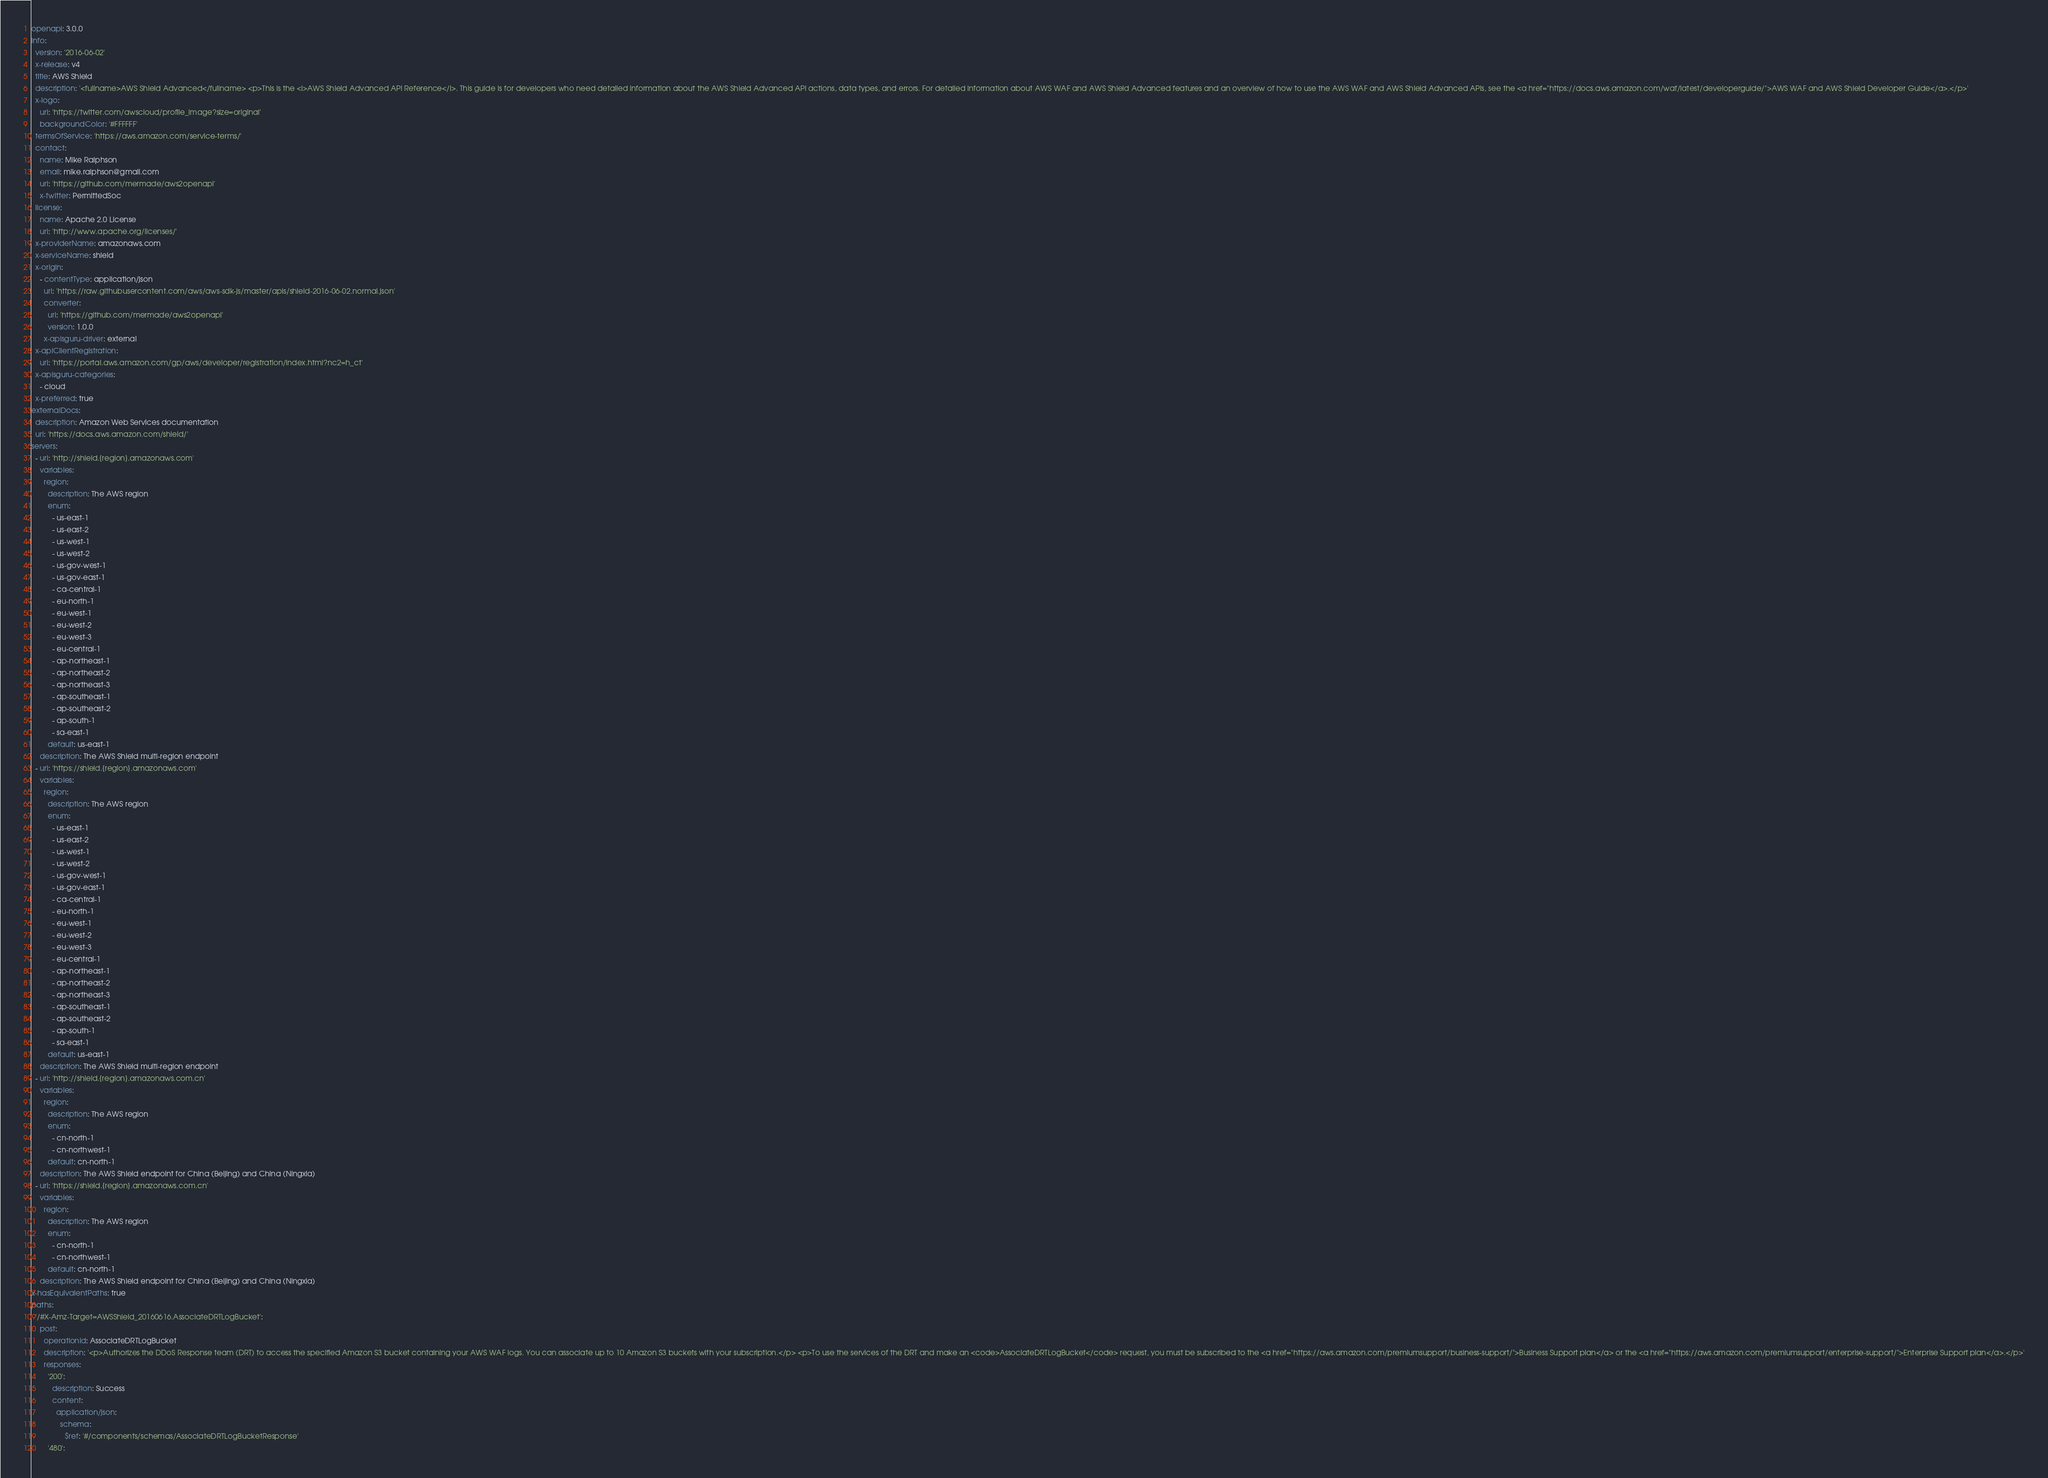Convert code to text. <code><loc_0><loc_0><loc_500><loc_500><_YAML_>openapi: 3.0.0
info:
  version: '2016-06-02'
  x-release: v4
  title: AWS Shield
  description: '<fullname>AWS Shield Advanced</fullname> <p>This is the <i>AWS Shield Advanced API Reference</i>. This guide is for developers who need detailed information about the AWS Shield Advanced API actions, data types, and errors. For detailed information about AWS WAF and AWS Shield Advanced features and an overview of how to use the AWS WAF and AWS Shield Advanced APIs, see the <a href="https://docs.aws.amazon.com/waf/latest/developerguide/">AWS WAF and AWS Shield Developer Guide</a>.</p>'
  x-logo:
    url: 'https://twitter.com/awscloud/profile_image?size=original'
    backgroundColor: '#FFFFFF'
  termsOfService: 'https://aws.amazon.com/service-terms/'
  contact:
    name: Mike Ralphson
    email: mike.ralphson@gmail.com
    url: 'https://github.com/mermade/aws2openapi'
    x-twitter: PermittedSoc
  license:
    name: Apache 2.0 License
    url: 'http://www.apache.org/licenses/'
  x-providerName: amazonaws.com
  x-serviceName: shield
  x-origin:
    - contentType: application/json
      url: 'https://raw.githubusercontent.com/aws/aws-sdk-js/master/apis/shield-2016-06-02.normal.json'
      converter:
        url: 'https://github.com/mermade/aws2openapi'
        version: 1.0.0
      x-apisguru-driver: external
  x-apiClientRegistration:
    url: 'https://portal.aws.amazon.com/gp/aws/developer/registration/index.html?nc2=h_ct'
  x-apisguru-categories:
    - cloud
  x-preferred: true
externalDocs:
  description: Amazon Web Services documentation
  url: 'https://docs.aws.amazon.com/shield/'
servers:
  - url: 'http://shield.{region}.amazonaws.com'
    variables:
      region:
        description: The AWS region
        enum:
          - us-east-1
          - us-east-2
          - us-west-1
          - us-west-2
          - us-gov-west-1
          - us-gov-east-1
          - ca-central-1
          - eu-north-1
          - eu-west-1
          - eu-west-2
          - eu-west-3
          - eu-central-1
          - ap-northeast-1
          - ap-northeast-2
          - ap-northeast-3
          - ap-southeast-1
          - ap-southeast-2
          - ap-south-1
          - sa-east-1
        default: us-east-1
    description: The AWS Shield multi-region endpoint
  - url: 'https://shield.{region}.amazonaws.com'
    variables:
      region:
        description: The AWS region
        enum:
          - us-east-1
          - us-east-2
          - us-west-1
          - us-west-2
          - us-gov-west-1
          - us-gov-east-1
          - ca-central-1
          - eu-north-1
          - eu-west-1
          - eu-west-2
          - eu-west-3
          - eu-central-1
          - ap-northeast-1
          - ap-northeast-2
          - ap-northeast-3
          - ap-southeast-1
          - ap-southeast-2
          - ap-south-1
          - sa-east-1
        default: us-east-1
    description: The AWS Shield multi-region endpoint
  - url: 'http://shield.{region}.amazonaws.com.cn'
    variables:
      region:
        description: The AWS region
        enum:
          - cn-north-1
          - cn-northwest-1
        default: cn-north-1
    description: The AWS Shield endpoint for China (Beijing) and China (Ningxia)
  - url: 'https://shield.{region}.amazonaws.com.cn'
    variables:
      region:
        description: The AWS region
        enum:
          - cn-north-1
          - cn-northwest-1
        default: cn-north-1
    description: The AWS Shield endpoint for China (Beijing) and China (Ningxia)
x-hasEquivalentPaths: true
paths:
  '/#X-Amz-Target=AWSShield_20160616.AssociateDRTLogBucket':
    post:
      operationId: AssociateDRTLogBucket
      description: '<p>Authorizes the DDoS Response team (DRT) to access the specified Amazon S3 bucket containing your AWS WAF logs. You can associate up to 10 Amazon S3 buckets with your subscription.</p> <p>To use the services of the DRT and make an <code>AssociateDRTLogBucket</code> request, you must be subscribed to the <a href="https://aws.amazon.com/premiumsupport/business-support/">Business Support plan</a> or the <a href="https://aws.amazon.com/premiumsupport/enterprise-support/">Enterprise Support plan</a>.</p>'
      responses:
        '200':
          description: Success
          content:
            application/json:
              schema:
                $ref: '#/components/schemas/AssociateDRTLogBucketResponse'
        '480':</code> 